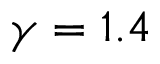Convert formula to latex. <formula><loc_0><loc_0><loc_500><loc_500>\gamma = 1 . 4</formula> 